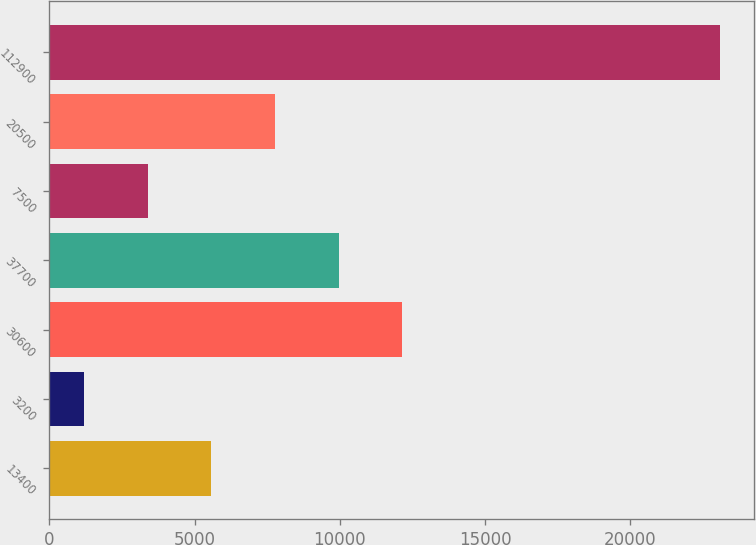Convert chart. <chart><loc_0><loc_0><loc_500><loc_500><bar_chart><fcel>13400<fcel>3200<fcel>30600<fcel>37700<fcel>7500<fcel>20500<fcel>112900<nl><fcel>5580<fcel>1200<fcel>12150<fcel>9960<fcel>3390<fcel>7770<fcel>23100<nl></chart> 